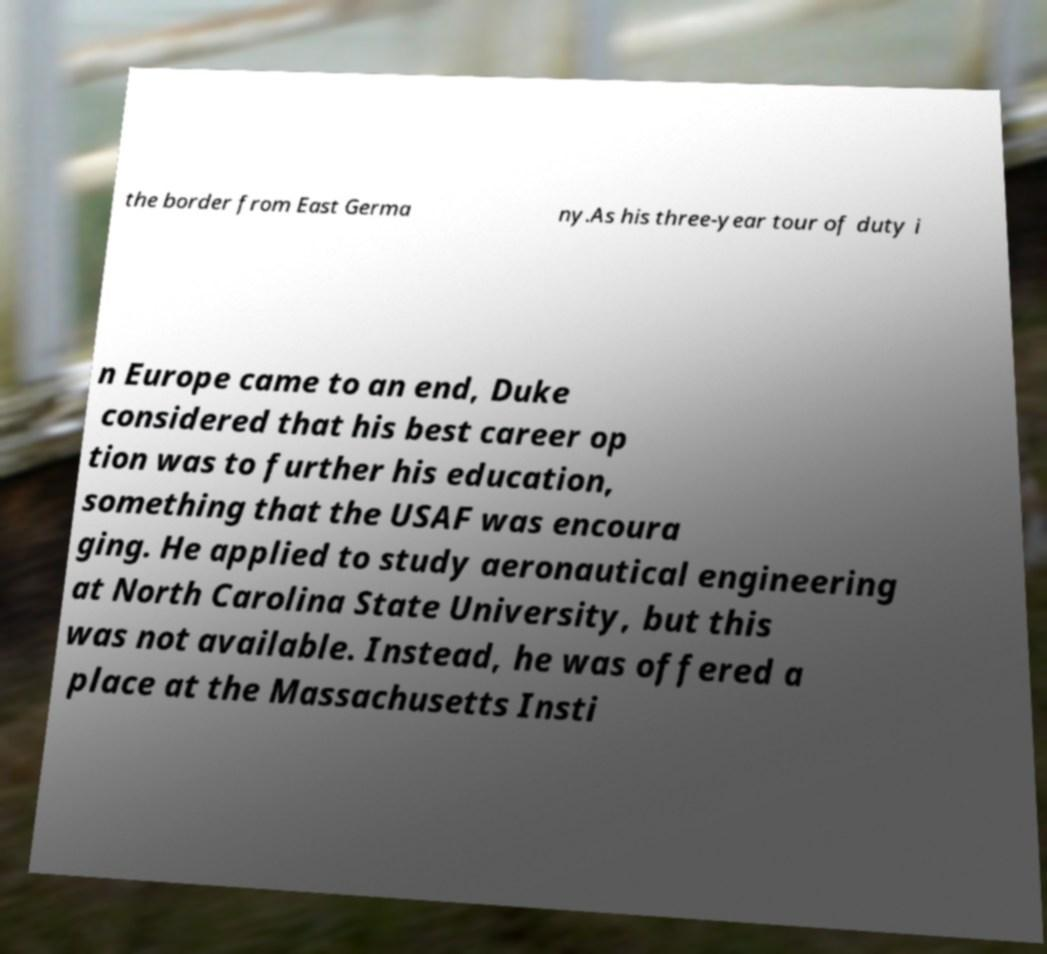Can you read and provide the text displayed in the image?This photo seems to have some interesting text. Can you extract and type it out for me? the border from East Germa ny.As his three-year tour of duty i n Europe came to an end, Duke considered that his best career op tion was to further his education, something that the USAF was encoura ging. He applied to study aeronautical engineering at North Carolina State University, but this was not available. Instead, he was offered a place at the Massachusetts Insti 